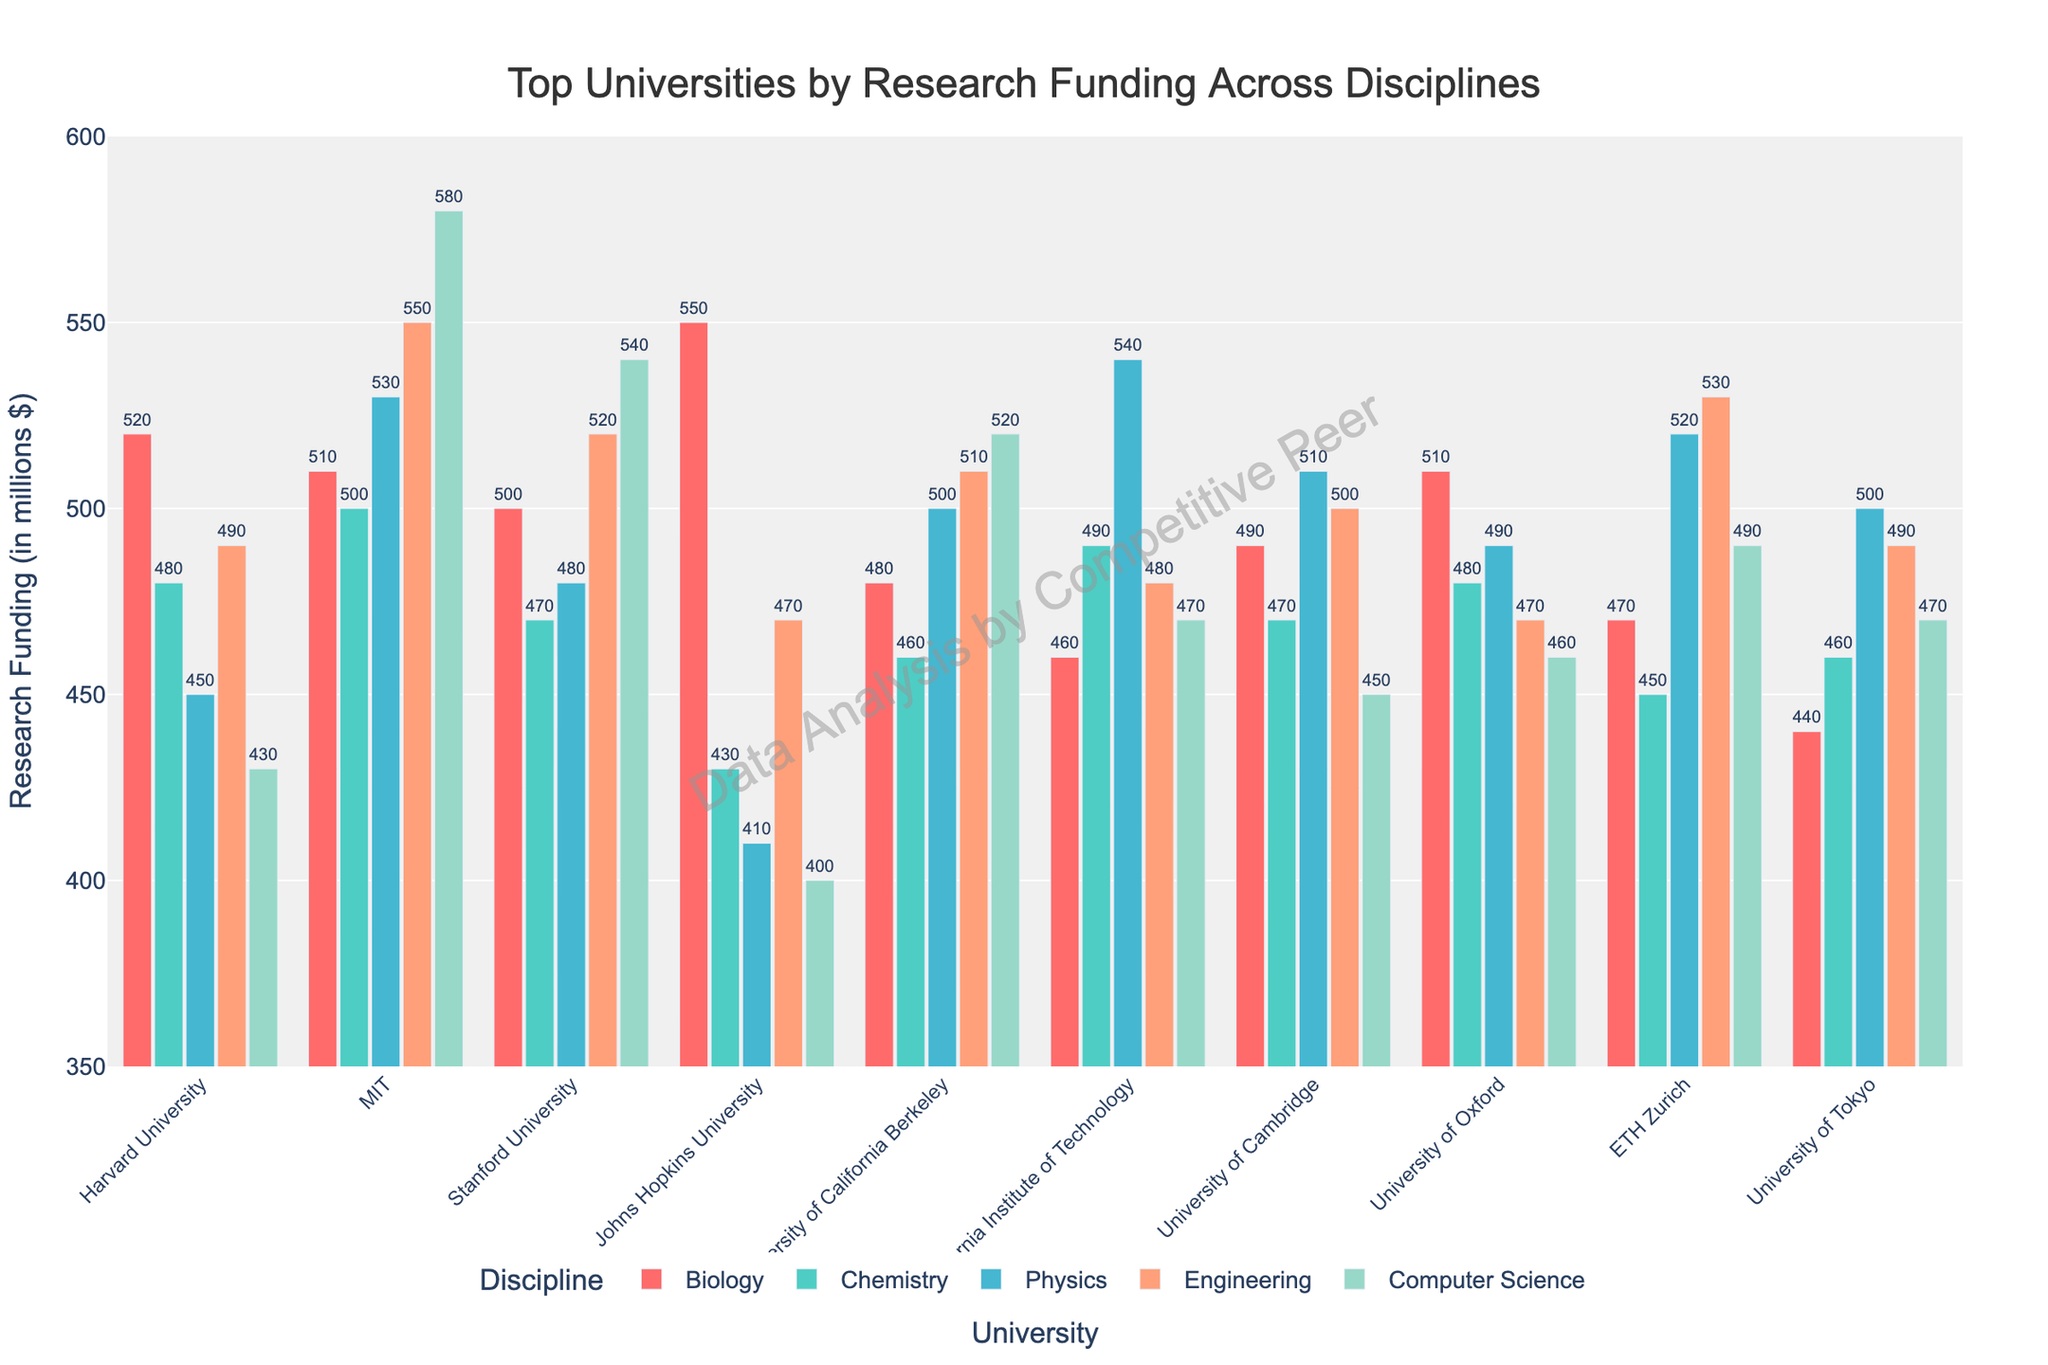Which university has the highest research funding in Chemistry? Compare the heights of the bars for Chemistry across all universities; the university whose bar is the tallest has the highest funding.
Answer: MIT What is the combined research funding for Harvard University in Biology and Engineering? Identify the heights of the bars for Biology and Engineering for Harvard University. Biology funding is $520 million and Engineering funding is $490 million. Sum these amounts: 520 + 490.
Answer: 1010 Which university has a higher research funding in Physics, Stanford University or ETH Zurich? Compare the heights of the bars for Physics for both Stanford University and ETH Zurich. Stanford's funding is $480 million, while ETH Zurich's funding is $520 million.
Answer: ETH Zurich What is the average research funding for University of Oxford across all five disciplines? Sum the research funding for University of Oxford across all disciplines (510 + 480 + 490 + 470 + 460) and divide by the number of disciplines (5). (510 + 480 + 490 + 470 + 460) / 5 = 2410 / 5
Answer: 482 Which discipline has the lowest research funding at Johns Hopkins University? Compare the heights of the bars for all disciplines at Johns Hopkins University. The lowest bar corresponds to Physics with $410 million.
Answer: Physics How much more funding does MIT have in Computer Science compared to University of Tokyo? Subtract the Computer Science funding of University of Tokyo ($470 million) from the Computer Science funding of MIT ($580 million): 580 - 470.
Answer: 110 